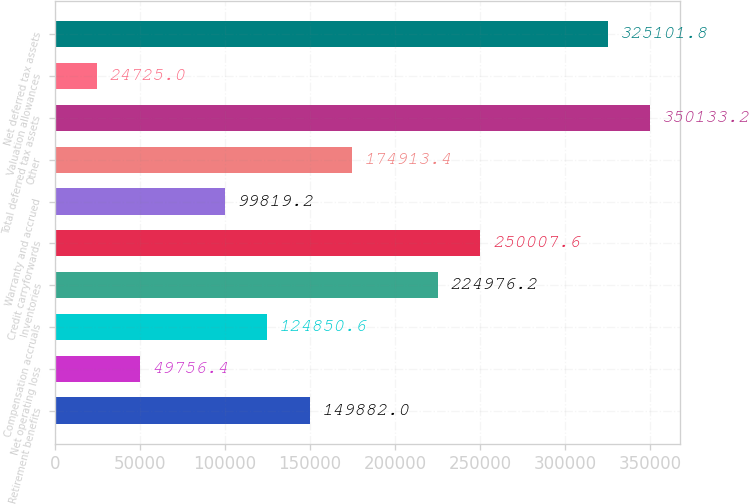Convert chart to OTSL. <chart><loc_0><loc_0><loc_500><loc_500><bar_chart><fcel>Retirement benefits<fcel>Net operating loss<fcel>Compensation accruals<fcel>Inventories<fcel>Credit carryforwards<fcel>Warranty and accrued<fcel>Other<fcel>Total deferred tax assets<fcel>Valuation allowances<fcel>Net deferred tax assets<nl><fcel>149882<fcel>49756.4<fcel>124851<fcel>224976<fcel>250008<fcel>99819.2<fcel>174913<fcel>350133<fcel>24725<fcel>325102<nl></chart> 